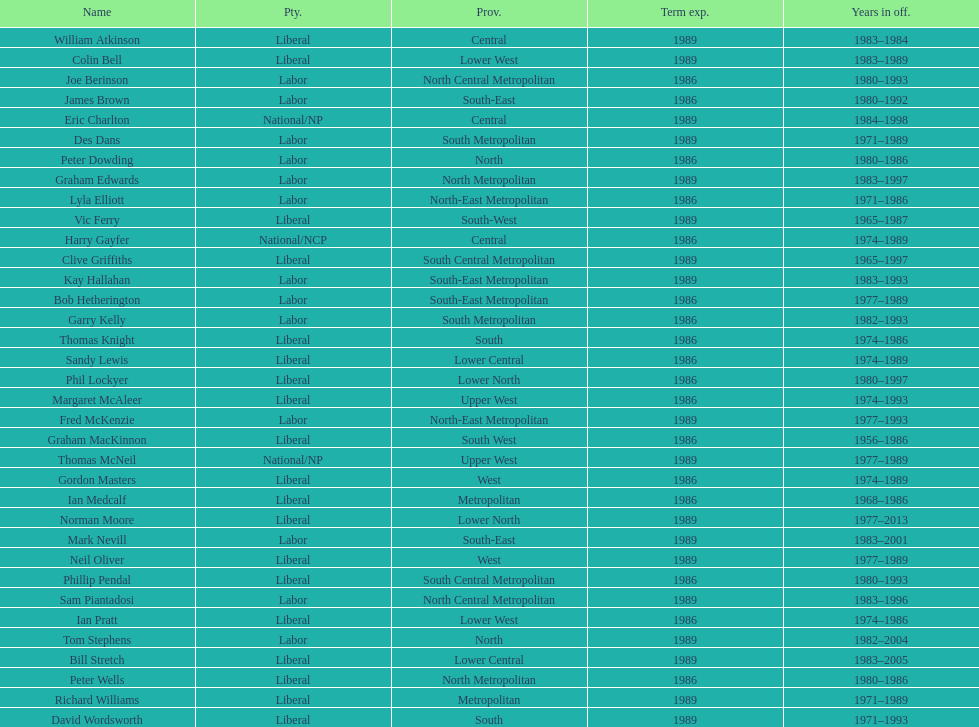Which party has the most membership? Liberal. 